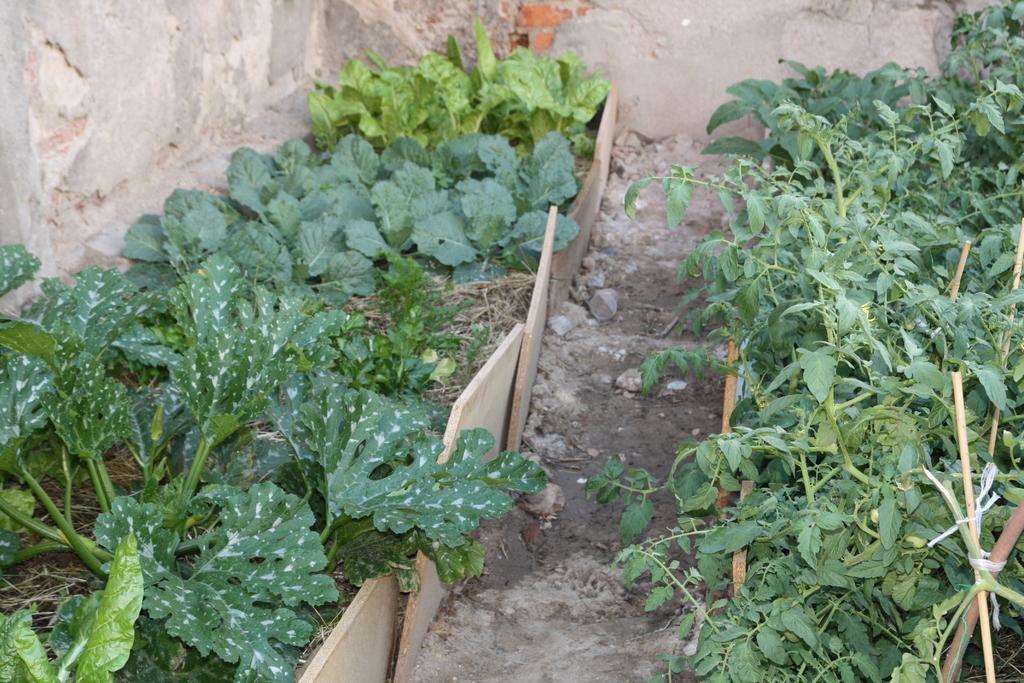How would you summarize this image in a sentence or two? In this image I can see few green color plants and boards. Back I can see a wall. 